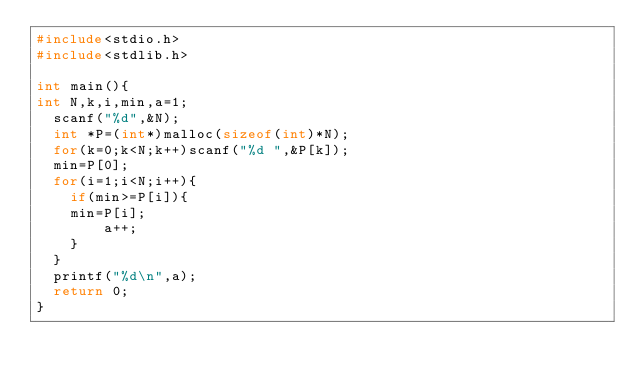Convert code to text. <code><loc_0><loc_0><loc_500><loc_500><_C_>#include<stdio.h>
#include<stdlib.h>

int main(){
int N,k,i,min,a=1;
  scanf("%d",&N);
  int *P=(int*)malloc(sizeof(int)*N);
  for(k=0;k<N;k++)scanf("%d ",&P[k]);
  min=P[0];
  for(i=1;i<N;i++){
  	if(min>=P[i]){
		min=P[i];
      	a++;
    }
  }
  printf("%d\n",a);
  return 0;
}
</code> 